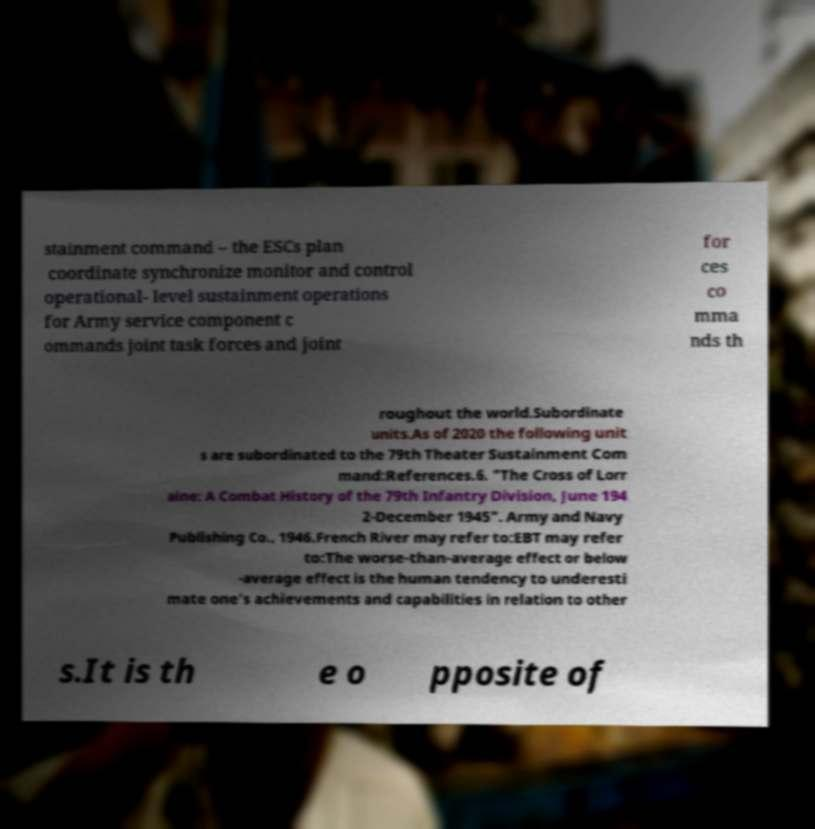Can you accurately transcribe the text from the provided image for me? stainment command – the ESCs plan coordinate synchronize monitor and control operational- level sustainment operations for Army service component c ommands joint task forces and joint for ces co mma nds th roughout the world.Subordinate units.As of 2020 the following unit s are subordinated to the 79th Theater Sustainment Com mand:References.6. "The Cross of Lorr aine: A Combat History of the 79th Infantry Division, June 194 2-December 1945". Army and Navy Publishing Co., 1946.French River may refer to:EBT may refer to:The worse-than-average effect or below -average effect is the human tendency to underesti mate one's achievements and capabilities in relation to other s.It is th e o pposite of 